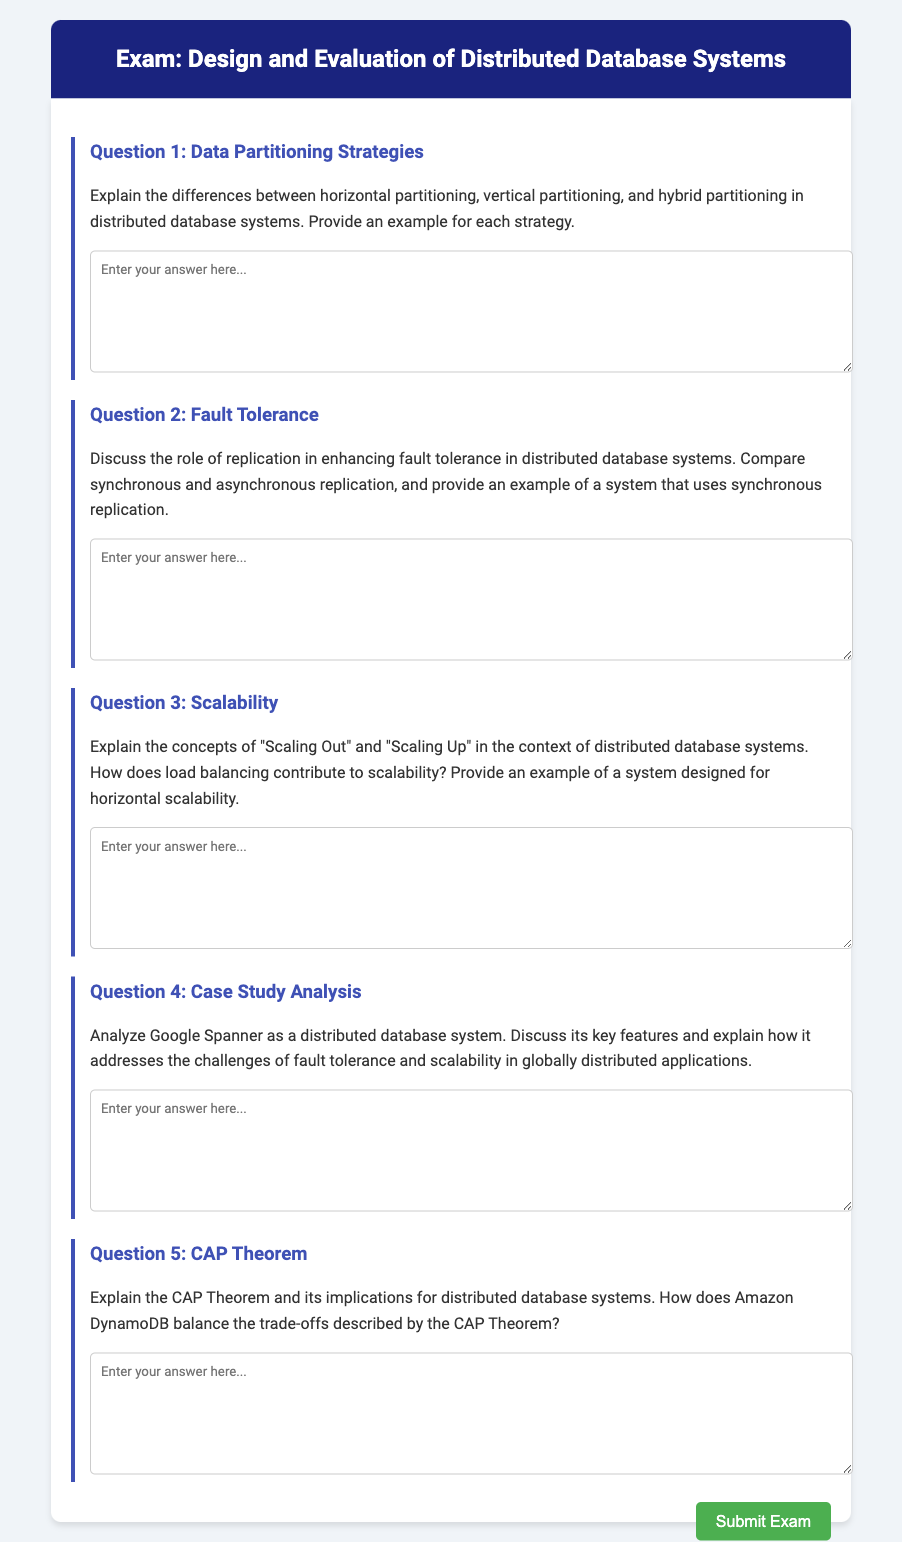What is the title of the exam? The title of the exam is stated in the header of the document.
Answer: Design and Evaluation of Distributed Database Systems How many questions are included in the exam? The number of questions can be counted from the content sections of the document.
Answer: Five What is the focus of Question 1? The focus of Question 1 is detailed in the question's heading, which indicates its topic.
Answer: Data Partitioning Strategies What unique feature does Google Spanner provide? The unique feature is referenced in the context of the analysis requested in Question 4.
Answer: Fault tolerance and scalability What are the two types of replication discussed in Question 2? The types of replication are specified in the instructions of Question 2.
Answer: Synchronous and asynchronous Which database system is mentioned as an example of synchronous replication? The specific system that uses synchronous replication is requested in Question 2.
Answer: Google Spanner What concepts are explained in Question 3? The question indicates specific concepts that are to be addressed.
Answer: Scaling Out and Scaling Up What theorem is the focus of Question 5? The theorem is directly mentioned in the title of Question 5.
Answer: CAP Theorem What aspect of distributed database systems does load balancing contribute to? The contribution of load balancing is mentioned in the context of Question 3.
Answer: Scalability 